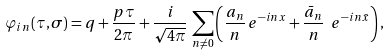Convert formula to latex. <formula><loc_0><loc_0><loc_500><loc_500>\varphi _ { i n } ( \tau , \sigma ) = q + \frac { p \tau } { 2 \pi } + \frac { i } { \sqrt { 4 \pi } } \, \sum _ { n \neq 0 } \left ( \frac { a _ { n } } { n } \, e ^ { - i n x } + \frac { \bar { a } _ { n } } { n } \ e ^ { - i n \bar { x } } \right ) ,</formula> 